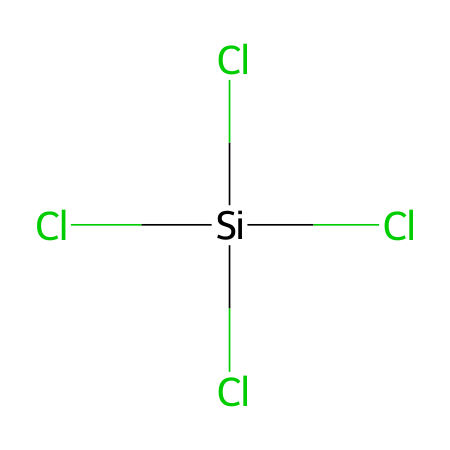How many chlorine atoms are in this chemical? From the SMILES representation, there are four chlorine atoms represented by "Cl" before and after the silicon atom.
Answer: four What is the central atom in this chlorosilane? The central atom is indicated by the brackets in the SMILES notation, which shows that silicon (Si) is at the center of the chlorosilane structure.
Answer: silicon How many total bonds are present in this compound? Each chlorine atom is bonded to the silicon atom, making four single bonds in total (as indicated by the structure). Therefore, there are four bonds overall.
Answer: four What type of chemical is represented by the structure? The presence of silicon bonded with chlorine indicates that this compound is classified as a chlorosilane.
Answer: chlorosilane What is the molecular geometry of this chlorosilane compound? Based on the tetrahedral arrangement that four substituents (chlorine atoms) create around the silicon atom, the molecular geometry is tetrahedral.
Answer: tetrahedral How does the presence of chlorine affect the reactivity of silanes? Chlorine atoms enhance the reactivity of silanes due to their electronegative nature, making this chlorosilane more reactive compared to non-chlorinated silanes.
Answer: higher reactivity Is this chlorosilane likely to be used in cleaning historical artifacts? Chlorosilanes are often employed as cleaning agents due to their ability to form siloxane bonds and effectively remove contaminants during restoration processes.
Answer: yes 